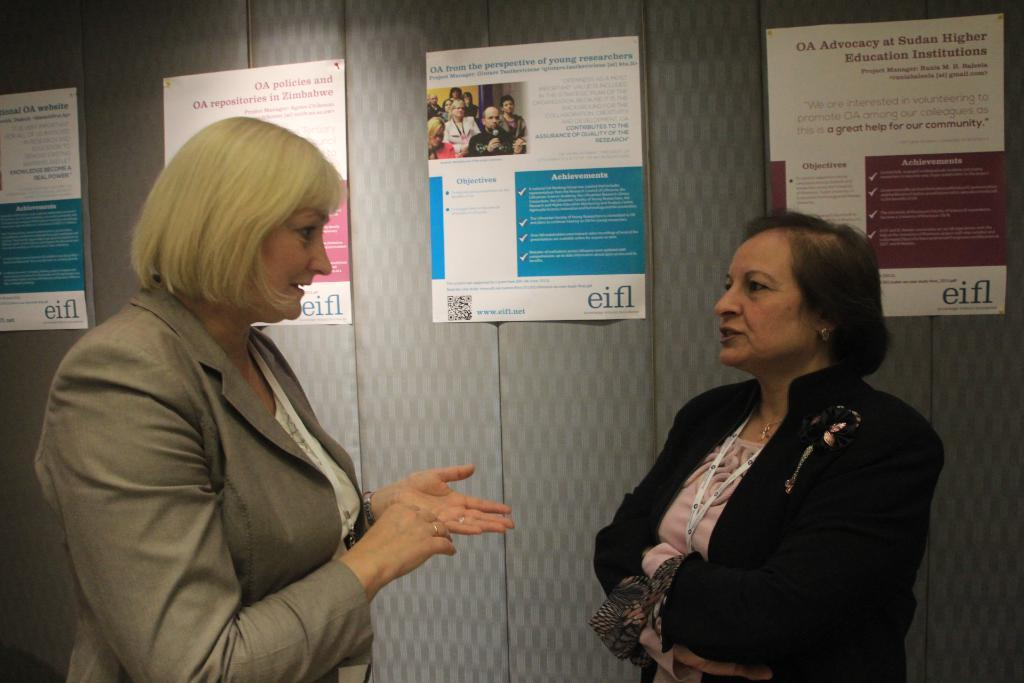How many people are in the image? There are 2 women in the image. What are the women doing in the image? The women are standing and talking to each other. What type of clothing are the women wearing? The women are wearing blazers. What can be seen in the background of the image? There are posters visible in the background. What type of ornament is hanging from the sleet in the image? There is no sleet or ornament present in the image. How does the jam affect the conversation between the women in the image? There is no jam present in the image, so it cannot affect the conversation between the women. 